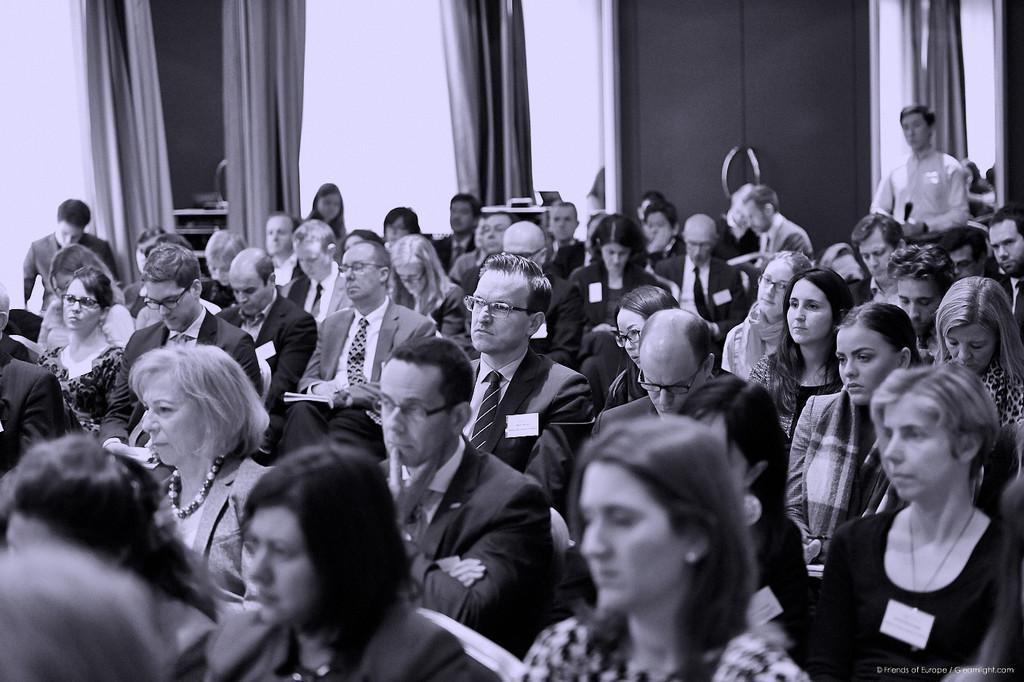Describe this image in one or two sentences. In this image I see number of people who are sitting and I see this man is standing and in the background I see the wall and I see the curtains. 